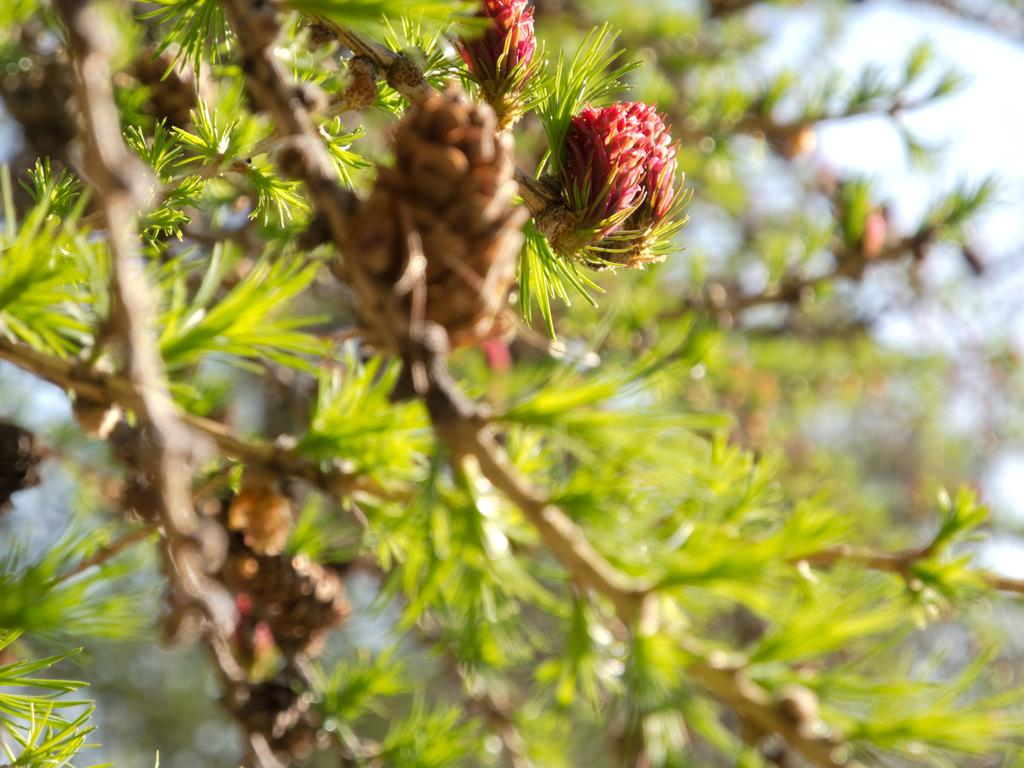What color are the fruits in the image? The fruits in the image are red. Where are the fruits located? The fruits are on a green plant. Can you describe the background of the image? The background of the image is blurred. How many legs can be seen on the pigs in the image? There are no pigs present in the image, so it is not possible to determine the number of legs. 